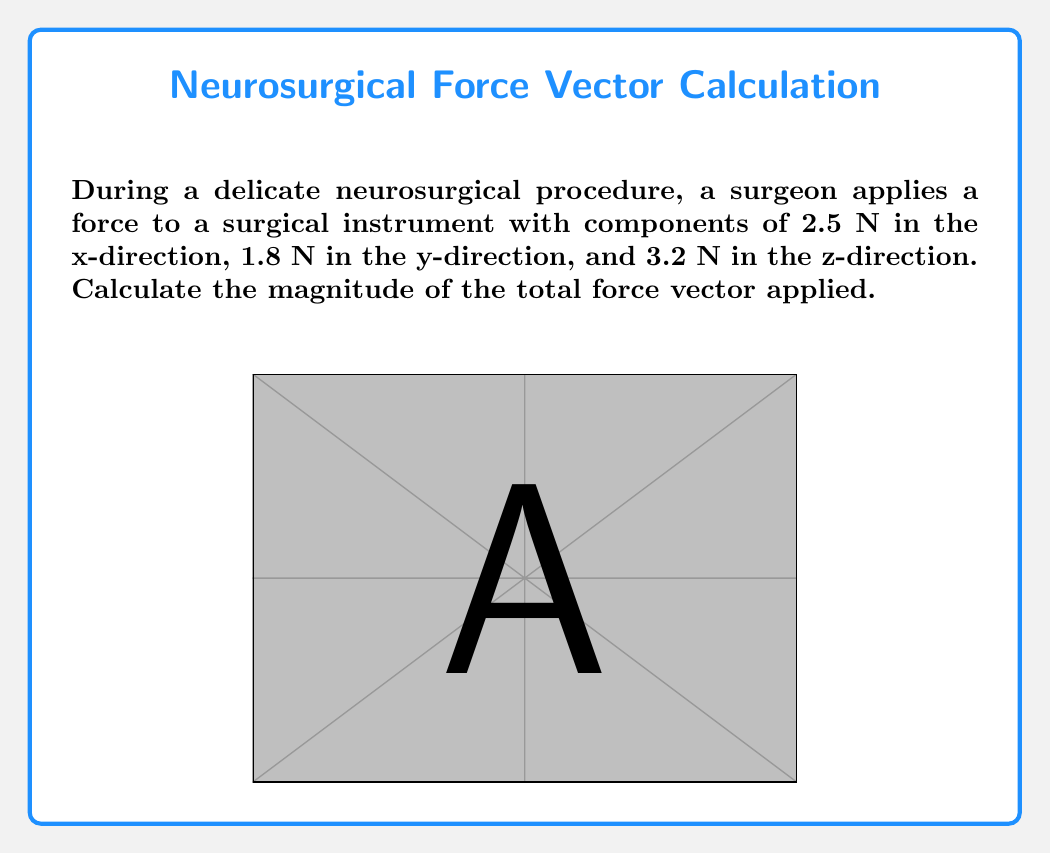Help me with this question. To calculate the magnitude of the force vector, we'll use the following steps:

1) The force vector $\vec{F}$ is given by its components:
   $$\vec{F} = (2.5\hat{i} + 1.8\hat{j} + 3.2\hat{k})\ \text{N}$$

2) The magnitude of a vector is calculated using the Pythagorean theorem in three dimensions:
   $$|\vec{F}| = \sqrt{F_x^2 + F_y^2 + F_z^2}$$

3) Substituting the given values:
   $$|\vec{F}| = \sqrt{(2.5)^2 + (1.8)^2 + (3.2)^2}\ \text{N}$$

4) Calculate the squares:
   $$|\vec{F}| = \sqrt{6.25 + 3.24 + 10.24}\ \text{N}$$

5) Sum the values under the square root:
   $$|\vec{F}| = \sqrt{19.73}\ \text{N}$$

6) Calculate the square root:
   $$|\vec{F}| \approx 4.44\ \text{N}$$

Therefore, the magnitude of the total force vector applied during the neurosurgical procedure is approximately 4.44 N.
Answer: $4.44\ \text{N}$ 